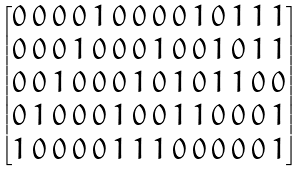<formula> <loc_0><loc_0><loc_500><loc_500>\begin{bmatrix} 0 \, 0 \, 0 \, 0 \, 1 \, 0 \, 0 \, 0 \, 0 \, 1 \, 0 \, 1 \, 1 \, 1 \\ 0 \, 0 \, 0 \, 1 \, 0 \, 0 \, 0 \, 1 \, 0 \, 0 \, 1 \, 0 \, 1 \, 1 \\ 0 \, 0 \, 1 \, 0 \, 0 \, 0 \, 1 \, 0 \, 1 \, 0 \, 1 \, 1 \, 0 \, 0 \\ 0 \, 1 \, 0 \, 0 \, 0 \, 1 \, 0 \, 0 \, 1 \, 1 \, 0 \, 0 \, 0 \, 1 \\ 1 \, 0 \, 0 \, 0 \, 0 \, 1 \, 1 \, 1 \, 0 \, 0 \, 0 \, 0 \, 0 \, 1 \end{bmatrix}</formula> 